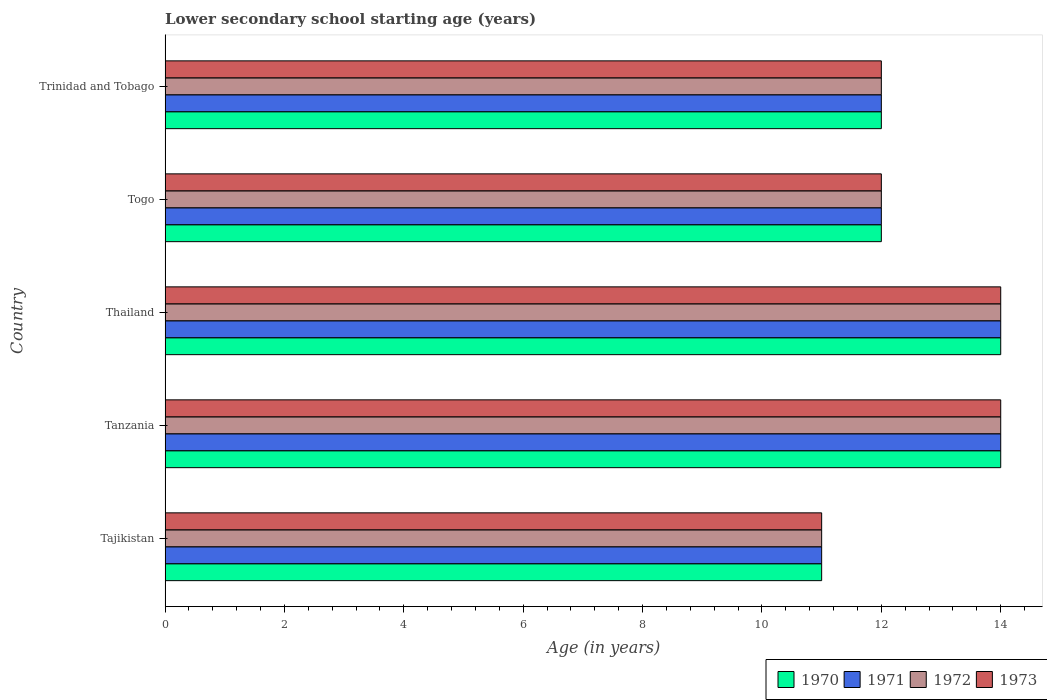How many groups of bars are there?
Your answer should be very brief. 5. Are the number of bars per tick equal to the number of legend labels?
Provide a succinct answer. Yes. How many bars are there on the 1st tick from the top?
Give a very brief answer. 4. What is the label of the 3rd group of bars from the top?
Make the answer very short. Thailand. Across all countries, what is the minimum lower secondary school starting age of children in 1971?
Ensure brevity in your answer.  11. In which country was the lower secondary school starting age of children in 1971 maximum?
Provide a succinct answer. Tanzania. In which country was the lower secondary school starting age of children in 1970 minimum?
Make the answer very short. Tajikistan. What is the total lower secondary school starting age of children in 1973 in the graph?
Provide a short and direct response. 63. What is the difference between the lower secondary school starting age of children in 1971 in Tajikistan and that in Tanzania?
Ensure brevity in your answer.  -3. What is the difference between the lower secondary school starting age of children in 1971 in Togo and the lower secondary school starting age of children in 1973 in Tanzania?
Provide a short and direct response. -2. What is the average lower secondary school starting age of children in 1973 per country?
Your answer should be very brief. 12.6. What is the difference between the lower secondary school starting age of children in 1972 and lower secondary school starting age of children in 1971 in Trinidad and Tobago?
Your answer should be compact. 0. In how many countries, is the lower secondary school starting age of children in 1973 greater than 9.2 years?
Provide a short and direct response. 5. What is the ratio of the lower secondary school starting age of children in 1972 in Tanzania to that in Trinidad and Tobago?
Offer a very short reply. 1.17. Is the lower secondary school starting age of children in 1970 in Tajikistan less than that in Togo?
Keep it short and to the point. Yes. Is the difference between the lower secondary school starting age of children in 1972 in Thailand and Trinidad and Tobago greater than the difference between the lower secondary school starting age of children in 1971 in Thailand and Trinidad and Tobago?
Ensure brevity in your answer.  No. What is the difference between the highest and the second highest lower secondary school starting age of children in 1970?
Give a very brief answer. 0. What is the difference between the highest and the lowest lower secondary school starting age of children in 1971?
Make the answer very short. 3. In how many countries, is the lower secondary school starting age of children in 1973 greater than the average lower secondary school starting age of children in 1973 taken over all countries?
Provide a succinct answer. 2. Is the sum of the lower secondary school starting age of children in 1973 in Tajikistan and Thailand greater than the maximum lower secondary school starting age of children in 1970 across all countries?
Ensure brevity in your answer.  Yes. What does the 1st bar from the top in Thailand represents?
Your response must be concise. 1973. How many countries are there in the graph?
Make the answer very short. 5. What is the difference between two consecutive major ticks on the X-axis?
Offer a terse response. 2. Are the values on the major ticks of X-axis written in scientific E-notation?
Offer a very short reply. No. Does the graph contain grids?
Offer a terse response. No. How are the legend labels stacked?
Offer a very short reply. Horizontal. What is the title of the graph?
Ensure brevity in your answer.  Lower secondary school starting age (years). What is the label or title of the X-axis?
Offer a terse response. Age (in years). What is the label or title of the Y-axis?
Provide a succinct answer. Country. What is the Age (in years) in 1971 in Tajikistan?
Make the answer very short. 11. What is the Age (in years) of 1973 in Tajikistan?
Offer a terse response. 11. What is the Age (in years) in 1970 in Tanzania?
Your response must be concise. 14. What is the Age (in years) of 1971 in Tanzania?
Your answer should be very brief. 14. What is the Age (in years) of 1970 in Thailand?
Make the answer very short. 14. What is the Age (in years) of 1973 in Thailand?
Provide a short and direct response. 14. What is the Age (in years) in 1971 in Togo?
Your answer should be compact. 12. What is the Age (in years) in 1973 in Togo?
Give a very brief answer. 12. What is the Age (in years) in 1971 in Trinidad and Tobago?
Your response must be concise. 12. Across all countries, what is the maximum Age (in years) of 1971?
Offer a terse response. 14. Across all countries, what is the maximum Age (in years) in 1973?
Your answer should be compact. 14. Across all countries, what is the minimum Age (in years) in 1971?
Provide a succinct answer. 11. Across all countries, what is the minimum Age (in years) of 1972?
Ensure brevity in your answer.  11. What is the total Age (in years) in 1973 in the graph?
Your answer should be very brief. 63. What is the difference between the Age (in years) of 1970 in Tajikistan and that in Tanzania?
Offer a very short reply. -3. What is the difference between the Age (in years) of 1971 in Tajikistan and that in Tanzania?
Ensure brevity in your answer.  -3. What is the difference between the Age (in years) in 1973 in Tajikistan and that in Tanzania?
Your response must be concise. -3. What is the difference between the Age (in years) in 1970 in Tajikistan and that in Thailand?
Your answer should be very brief. -3. What is the difference between the Age (in years) in 1971 in Tajikistan and that in Thailand?
Your response must be concise. -3. What is the difference between the Age (in years) of 1972 in Tajikistan and that in Togo?
Provide a succinct answer. -1. What is the difference between the Age (in years) in 1973 in Tajikistan and that in Togo?
Make the answer very short. -1. What is the difference between the Age (in years) in 1973 in Tajikistan and that in Trinidad and Tobago?
Keep it short and to the point. -1. What is the difference between the Age (in years) in 1971 in Tanzania and that in Thailand?
Your answer should be compact. 0. What is the difference between the Age (in years) in 1972 in Tanzania and that in Thailand?
Offer a very short reply. 0. What is the difference between the Age (in years) in 1970 in Tanzania and that in Togo?
Your answer should be compact. 2. What is the difference between the Age (in years) in 1971 in Tanzania and that in Togo?
Give a very brief answer. 2. What is the difference between the Age (in years) of 1972 in Tanzania and that in Togo?
Your answer should be compact. 2. What is the difference between the Age (in years) in 1973 in Tanzania and that in Togo?
Give a very brief answer. 2. What is the difference between the Age (in years) of 1970 in Tanzania and that in Trinidad and Tobago?
Make the answer very short. 2. What is the difference between the Age (in years) in 1971 in Tanzania and that in Trinidad and Tobago?
Your answer should be compact. 2. What is the difference between the Age (in years) of 1972 in Tanzania and that in Trinidad and Tobago?
Make the answer very short. 2. What is the difference between the Age (in years) of 1973 in Tanzania and that in Trinidad and Tobago?
Give a very brief answer. 2. What is the difference between the Age (in years) in 1970 in Thailand and that in Togo?
Offer a very short reply. 2. What is the difference between the Age (in years) of 1972 in Thailand and that in Togo?
Provide a succinct answer. 2. What is the difference between the Age (in years) of 1970 in Thailand and that in Trinidad and Tobago?
Make the answer very short. 2. What is the difference between the Age (in years) in 1971 in Thailand and that in Trinidad and Tobago?
Give a very brief answer. 2. What is the difference between the Age (in years) in 1972 in Thailand and that in Trinidad and Tobago?
Give a very brief answer. 2. What is the difference between the Age (in years) of 1973 in Thailand and that in Trinidad and Tobago?
Provide a succinct answer. 2. What is the difference between the Age (in years) of 1970 in Togo and that in Trinidad and Tobago?
Your answer should be compact. 0. What is the difference between the Age (in years) in 1970 in Tajikistan and the Age (in years) in 1971 in Tanzania?
Make the answer very short. -3. What is the difference between the Age (in years) of 1970 in Tajikistan and the Age (in years) of 1973 in Tanzania?
Your answer should be compact. -3. What is the difference between the Age (in years) of 1970 in Tajikistan and the Age (in years) of 1971 in Togo?
Provide a succinct answer. -1. What is the difference between the Age (in years) in 1970 in Tajikistan and the Age (in years) in 1973 in Togo?
Offer a very short reply. -1. What is the difference between the Age (in years) in 1971 in Tajikistan and the Age (in years) in 1973 in Togo?
Keep it short and to the point. -1. What is the difference between the Age (in years) of 1972 in Tajikistan and the Age (in years) of 1973 in Togo?
Make the answer very short. -1. What is the difference between the Age (in years) in 1970 in Tajikistan and the Age (in years) in 1971 in Trinidad and Tobago?
Keep it short and to the point. -1. What is the difference between the Age (in years) in 1970 in Tajikistan and the Age (in years) in 1972 in Trinidad and Tobago?
Your answer should be compact. -1. What is the difference between the Age (in years) in 1971 in Tajikistan and the Age (in years) in 1972 in Trinidad and Tobago?
Offer a very short reply. -1. What is the difference between the Age (in years) of 1970 in Tanzania and the Age (in years) of 1971 in Thailand?
Give a very brief answer. 0. What is the difference between the Age (in years) of 1970 in Tanzania and the Age (in years) of 1973 in Thailand?
Your answer should be very brief. 0. What is the difference between the Age (in years) in 1971 in Tanzania and the Age (in years) in 1973 in Thailand?
Make the answer very short. 0. What is the difference between the Age (in years) in 1970 in Tanzania and the Age (in years) in 1973 in Togo?
Your response must be concise. 2. What is the difference between the Age (in years) in 1971 in Tanzania and the Age (in years) in 1973 in Togo?
Keep it short and to the point. 2. What is the difference between the Age (in years) of 1972 in Tanzania and the Age (in years) of 1973 in Togo?
Offer a very short reply. 2. What is the difference between the Age (in years) in 1970 in Tanzania and the Age (in years) in 1973 in Trinidad and Tobago?
Give a very brief answer. 2. What is the difference between the Age (in years) of 1971 in Tanzania and the Age (in years) of 1972 in Trinidad and Tobago?
Your response must be concise. 2. What is the difference between the Age (in years) in 1971 in Tanzania and the Age (in years) in 1973 in Trinidad and Tobago?
Offer a very short reply. 2. What is the difference between the Age (in years) in 1972 in Tanzania and the Age (in years) in 1973 in Trinidad and Tobago?
Provide a succinct answer. 2. What is the difference between the Age (in years) in 1970 in Thailand and the Age (in years) in 1972 in Togo?
Provide a short and direct response. 2. What is the difference between the Age (in years) in 1970 in Thailand and the Age (in years) in 1973 in Togo?
Your answer should be very brief. 2. What is the difference between the Age (in years) of 1970 in Thailand and the Age (in years) of 1973 in Trinidad and Tobago?
Give a very brief answer. 2. What is the difference between the Age (in years) of 1971 in Thailand and the Age (in years) of 1973 in Trinidad and Tobago?
Keep it short and to the point. 2. What is the difference between the Age (in years) in 1970 in Togo and the Age (in years) in 1973 in Trinidad and Tobago?
Offer a very short reply. 0. What is the difference between the Age (in years) in 1971 in Togo and the Age (in years) in 1972 in Trinidad and Tobago?
Provide a succinct answer. 0. What is the difference between the Age (in years) in 1972 in Togo and the Age (in years) in 1973 in Trinidad and Tobago?
Your answer should be very brief. 0. What is the average Age (in years) of 1970 per country?
Keep it short and to the point. 12.6. What is the average Age (in years) in 1972 per country?
Give a very brief answer. 12.6. What is the difference between the Age (in years) of 1970 and Age (in years) of 1971 in Tajikistan?
Your answer should be compact. 0. What is the difference between the Age (in years) of 1971 and Age (in years) of 1973 in Tajikistan?
Ensure brevity in your answer.  0. What is the difference between the Age (in years) of 1972 and Age (in years) of 1973 in Tajikistan?
Your answer should be compact. 0. What is the difference between the Age (in years) of 1971 and Age (in years) of 1972 in Tanzania?
Your response must be concise. 0. What is the difference between the Age (in years) in 1970 and Age (in years) in 1971 in Thailand?
Provide a succinct answer. 0. What is the difference between the Age (in years) in 1971 and Age (in years) in 1972 in Thailand?
Make the answer very short. 0. What is the difference between the Age (in years) in 1971 and Age (in years) in 1973 in Thailand?
Offer a very short reply. 0. What is the difference between the Age (in years) in 1972 and Age (in years) in 1973 in Thailand?
Make the answer very short. 0. What is the difference between the Age (in years) of 1971 and Age (in years) of 1972 in Togo?
Your response must be concise. 0. What is the difference between the Age (in years) of 1970 and Age (in years) of 1972 in Trinidad and Tobago?
Your answer should be compact. 0. What is the difference between the Age (in years) of 1970 and Age (in years) of 1973 in Trinidad and Tobago?
Keep it short and to the point. 0. What is the ratio of the Age (in years) in 1970 in Tajikistan to that in Tanzania?
Keep it short and to the point. 0.79. What is the ratio of the Age (in years) of 1971 in Tajikistan to that in Tanzania?
Your answer should be compact. 0.79. What is the ratio of the Age (in years) of 1972 in Tajikistan to that in Tanzania?
Give a very brief answer. 0.79. What is the ratio of the Age (in years) in 1973 in Tajikistan to that in Tanzania?
Keep it short and to the point. 0.79. What is the ratio of the Age (in years) in 1970 in Tajikistan to that in Thailand?
Your answer should be compact. 0.79. What is the ratio of the Age (in years) in 1971 in Tajikistan to that in Thailand?
Offer a terse response. 0.79. What is the ratio of the Age (in years) in 1972 in Tajikistan to that in Thailand?
Your answer should be very brief. 0.79. What is the ratio of the Age (in years) of 1973 in Tajikistan to that in Thailand?
Keep it short and to the point. 0.79. What is the ratio of the Age (in years) of 1970 in Tajikistan to that in Togo?
Offer a very short reply. 0.92. What is the ratio of the Age (in years) in 1973 in Tajikistan to that in Togo?
Give a very brief answer. 0.92. What is the ratio of the Age (in years) in 1971 in Tajikistan to that in Trinidad and Tobago?
Keep it short and to the point. 0.92. What is the ratio of the Age (in years) in 1973 in Tajikistan to that in Trinidad and Tobago?
Offer a very short reply. 0.92. What is the ratio of the Age (in years) of 1970 in Tanzania to that in Thailand?
Provide a succinct answer. 1. What is the ratio of the Age (in years) of 1971 in Tanzania to that in Thailand?
Make the answer very short. 1. What is the ratio of the Age (in years) in 1972 in Tanzania to that in Thailand?
Your response must be concise. 1. What is the ratio of the Age (in years) of 1973 in Tanzania to that in Thailand?
Offer a terse response. 1. What is the ratio of the Age (in years) of 1972 in Tanzania to that in Togo?
Offer a terse response. 1.17. What is the ratio of the Age (in years) in 1972 in Tanzania to that in Trinidad and Tobago?
Provide a succinct answer. 1.17. What is the ratio of the Age (in years) of 1973 in Tanzania to that in Trinidad and Tobago?
Offer a terse response. 1.17. What is the ratio of the Age (in years) in 1971 in Thailand to that in Togo?
Offer a terse response. 1.17. What is the ratio of the Age (in years) of 1971 in Thailand to that in Trinidad and Tobago?
Your response must be concise. 1.17. What is the ratio of the Age (in years) in 1973 in Togo to that in Trinidad and Tobago?
Your response must be concise. 1. What is the difference between the highest and the second highest Age (in years) in 1973?
Give a very brief answer. 0. What is the difference between the highest and the lowest Age (in years) of 1971?
Provide a succinct answer. 3. What is the difference between the highest and the lowest Age (in years) in 1972?
Your response must be concise. 3. 